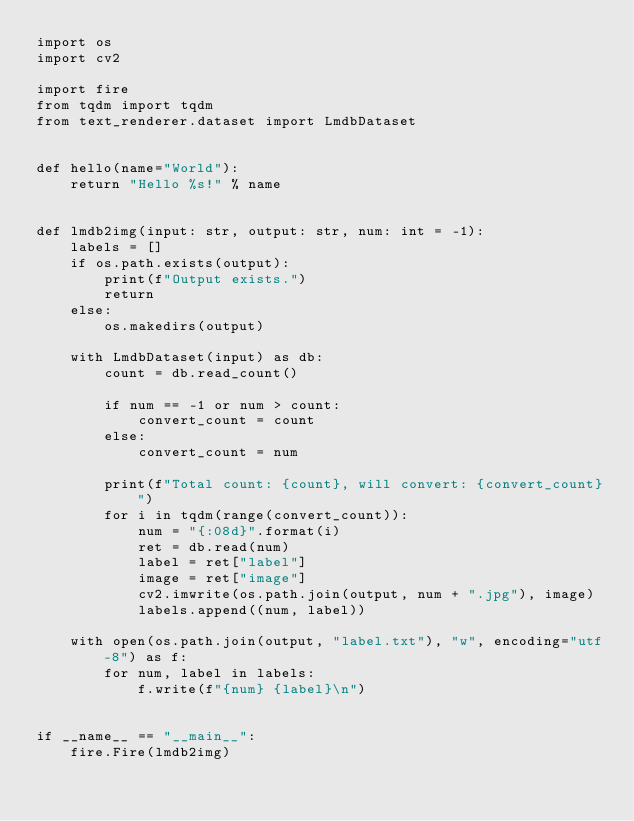<code> <loc_0><loc_0><loc_500><loc_500><_Python_>import os
import cv2

import fire
from tqdm import tqdm
from text_renderer.dataset import LmdbDataset


def hello(name="World"):
    return "Hello %s!" % name


def lmdb2img(input: str, output: str, num: int = -1):
    labels = []
    if os.path.exists(output):
        print(f"Output exists.")
        return
    else:
        os.makedirs(output)

    with LmdbDataset(input) as db:
        count = db.read_count()

        if num == -1 or num > count:
            convert_count = count
        else:
            convert_count = num

        print(f"Total count: {count}, will convert: {convert_count}")
        for i in tqdm(range(convert_count)):
            num = "{:08d}".format(i)
            ret = db.read(num)
            label = ret["label"]
            image = ret["image"]
            cv2.imwrite(os.path.join(output, num + ".jpg"), image)
            labels.append((num, label))

    with open(os.path.join(output, "label.txt"), "w", encoding="utf-8") as f:
        for num, label in labels:
            f.write(f"{num} {label}\n")


if __name__ == "__main__":
    fire.Fire(lmdb2img)
</code> 